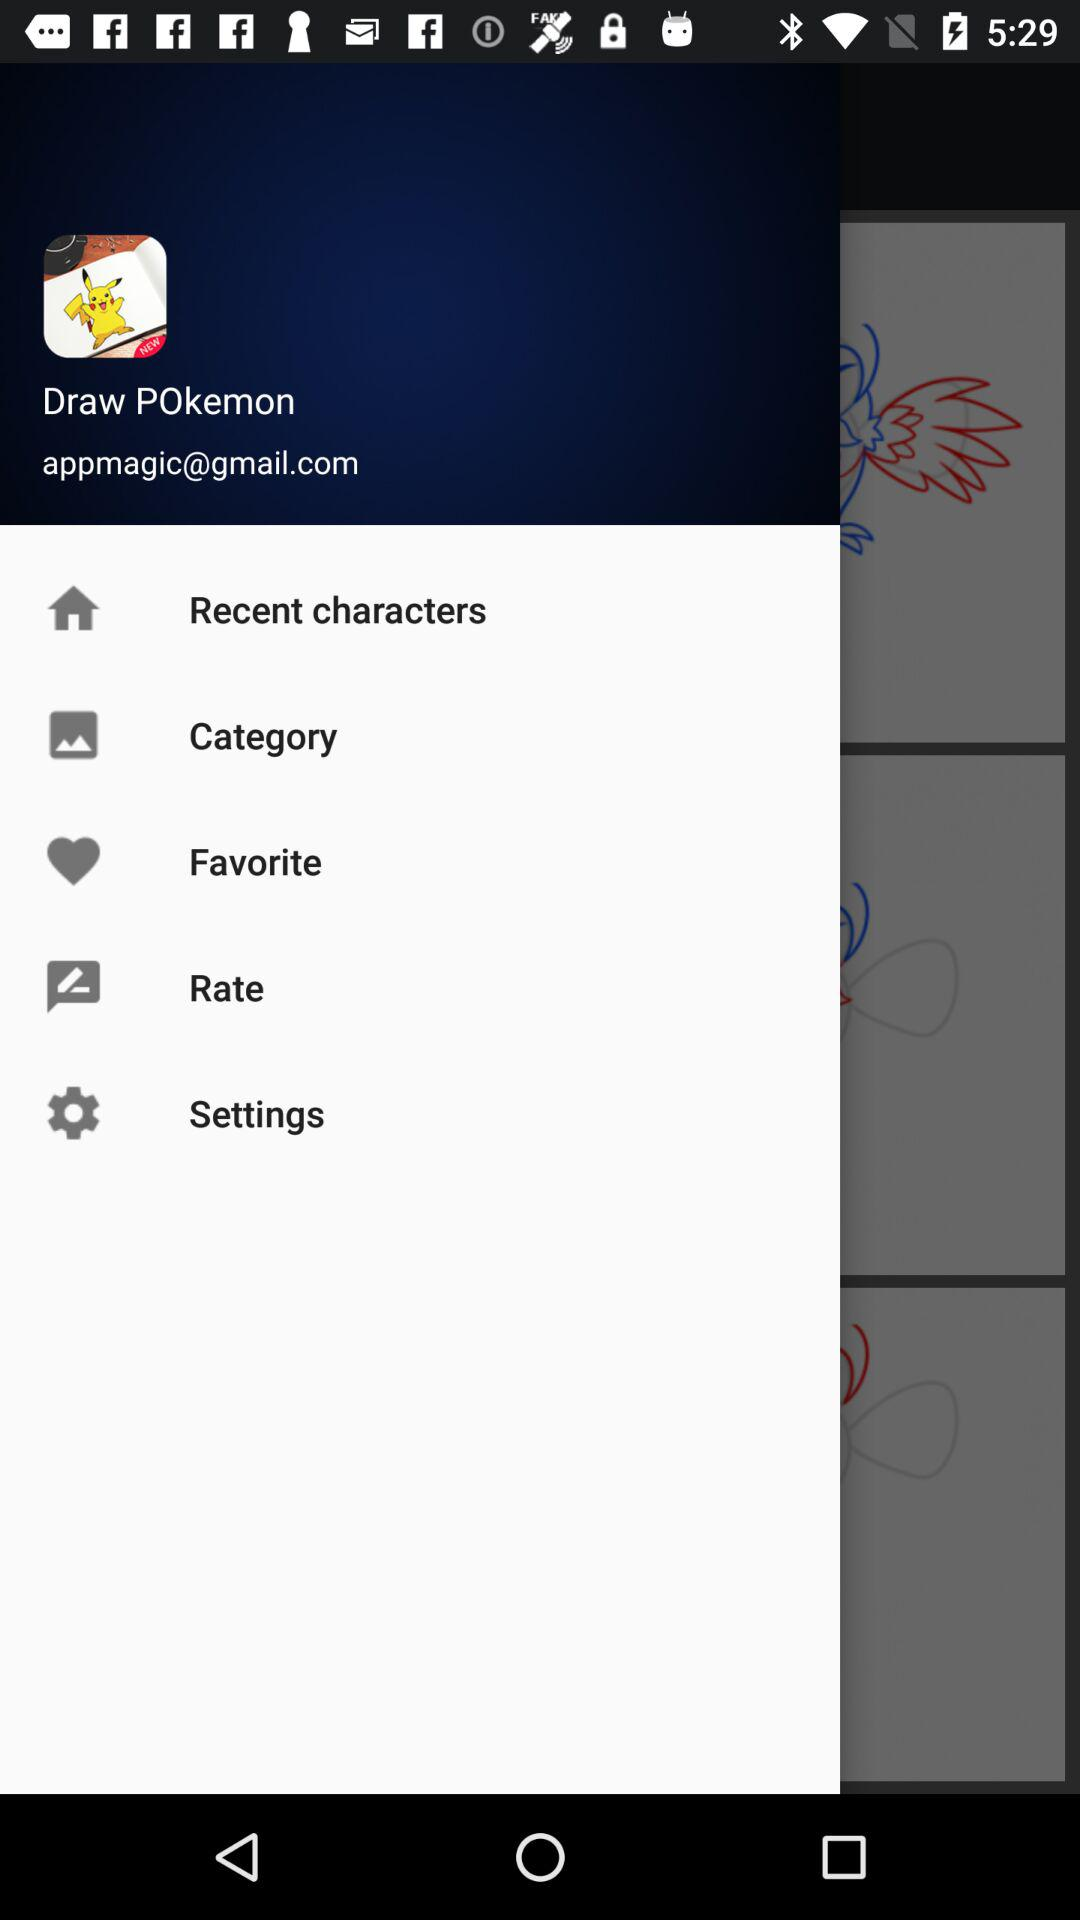What is the email address? The email address is appmagic@gmail.com. 